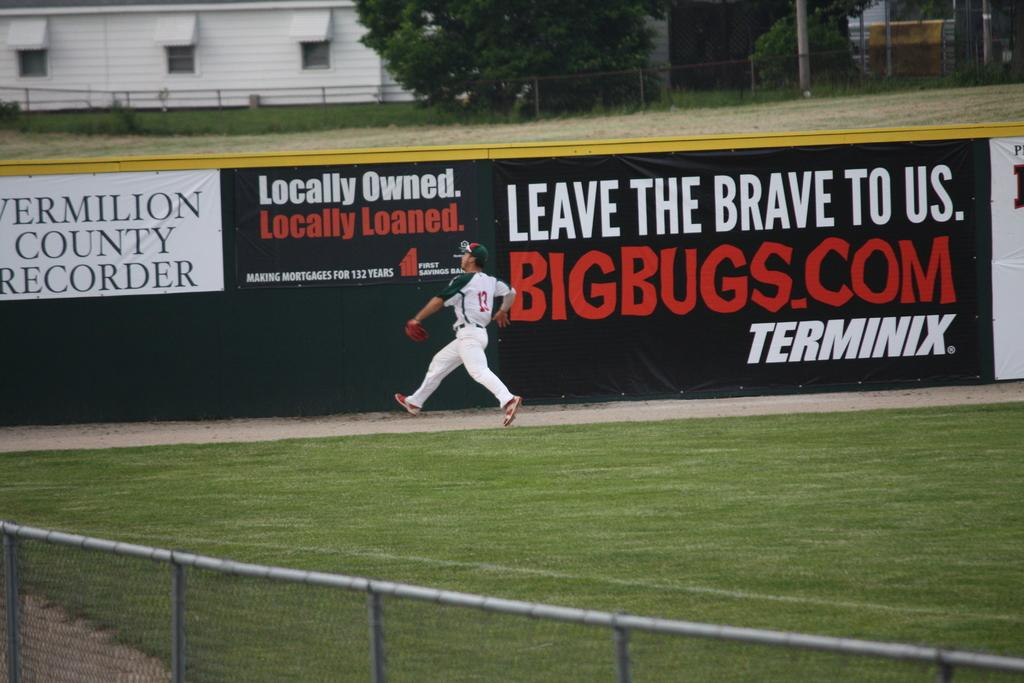<image>
Give a short and clear explanation of the subsequent image. Baseball player wearing number 13 going for the ball. 